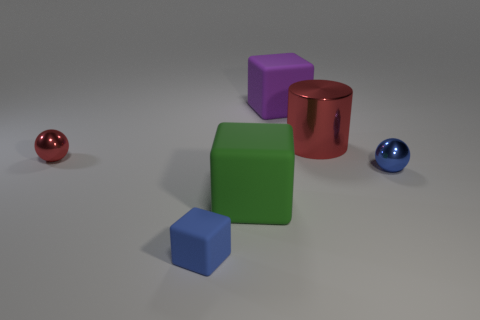The tiny thing that is on the left side of the green cube and behind the blue rubber thing is what color?
Offer a very short reply. Red. What size is the thing that is behind the red shiny object behind the small shiny object that is on the left side of the blue shiny ball?
Give a very brief answer. Large. What number of objects are either tiny shiny objects on the right side of the green matte object or tiny metal balls that are to the right of the large cylinder?
Offer a very short reply. 1. There is a big shiny object; what shape is it?
Provide a succinct answer. Cylinder. What number of other things are made of the same material as the big cylinder?
Your answer should be very brief. 2. What is the size of the purple matte object that is the same shape as the green matte thing?
Keep it short and to the point. Large. What is the sphere to the right of the big block that is behind the tiny shiny ball to the right of the small blue rubber cube made of?
Make the answer very short. Metal. Are there any brown rubber cylinders?
Your answer should be very brief. No. There is a small cube; is its color the same as the cube that is right of the green matte thing?
Make the answer very short. No. The tiny rubber object is what color?
Give a very brief answer. Blue. 